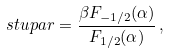<formula> <loc_0><loc_0><loc_500><loc_500>\ s t u p a r = \frac { \beta F _ { - 1 / 2 } ( \alpha ) } { F _ { 1 / 2 } ( \alpha ) } \, ,</formula> 